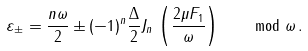Convert formula to latex. <formula><loc_0><loc_0><loc_500><loc_500>\varepsilon _ { \pm } = \frac { n \omega } { 2 } \pm ( - 1 ) ^ { n } \frac { \Delta } { 2 } J _ { n } \, \left ( \frac { 2 \mu F _ { 1 } } { \omega } \right ) \, \quad \bmod \omega \, .</formula> 